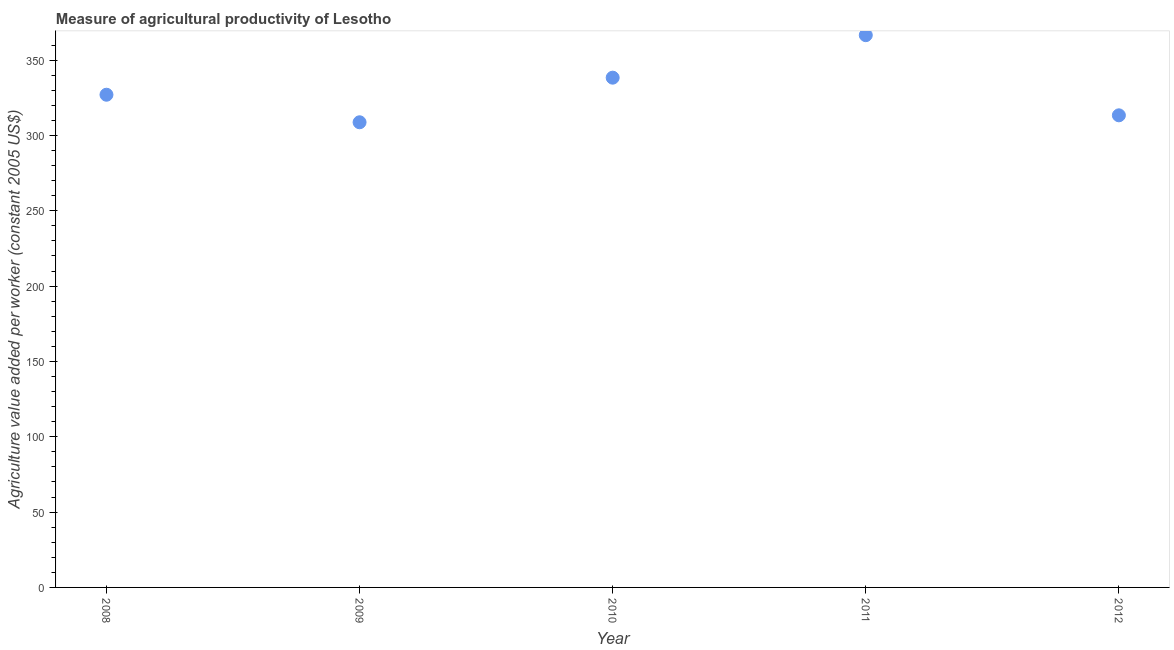What is the agriculture value added per worker in 2009?
Offer a very short reply. 308.73. Across all years, what is the maximum agriculture value added per worker?
Your answer should be very brief. 366.53. Across all years, what is the minimum agriculture value added per worker?
Ensure brevity in your answer.  308.73. In which year was the agriculture value added per worker maximum?
Your answer should be very brief. 2011. In which year was the agriculture value added per worker minimum?
Keep it short and to the point. 2009. What is the sum of the agriculture value added per worker?
Ensure brevity in your answer.  1653.95. What is the difference between the agriculture value added per worker in 2008 and 2012?
Offer a very short reply. 13.67. What is the average agriculture value added per worker per year?
Ensure brevity in your answer.  330.79. What is the median agriculture value added per worker?
Give a very brief answer. 327.01. What is the ratio of the agriculture value added per worker in 2010 to that in 2011?
Offer a very short reply. 0.92. Is the difference between the agriculture value added per worker in 2011 and 2012 greater than the difference between any two years?
Offer a very short reply. No. What is the difference between the highest and the second highest agriculture value added per worker?
Ensure brevity in your answer.  28.2. Is the sum of the agriculture value added per worker in 2009 and 2010 greater than the maximum agriculture value added per worker across all years?
Offer a very short reply. Yes. What is the difference between the highest and the lowest agriculture value added per worker?
Provide a short and direct response. 57.81. In how many years, is the agriculture value added per worker greater than the average agriculture value added per worker taken over all years?
Give a very brief answer. 2. Does the agriculture value added per worker monotonically increase over the years?
Keep it short and to the point. No. How many years are there in the graph?
Your answer should be very brief. 5. What is the difference between two consecutive major ticks on the Y-axis?
Provide a short and direct response. 50. Does the graph contain grids?
Make the answer very short. No. What is the title of the graph?
Keep it short and to the point. Measure of agricultural productivity of Lesotho. What is the label or title of the X-axis?
Provide a short and direct response. Year. What is the label or title of the Y-axis?
Your answer should be very brief. Agriculture value added per worker (constant 2005 US$). What is the Agriculture value added per worker (constant 2005 US$) in 2008?
Ensure brevity in your answer.  327.01. What is the Agriculture value added per worker (constant 2005 US$) in 2009?
Provide a succinct answer. 308.73. What is the Agriculture value added per worker (constant 2005 US$) in 2010?
Offer a terse response. 338.33. What is the Agriculture value added per worker (constant 2005 US$) in 2011?
Offer a terse response. 366.53. What is the Agriculture value added per worker (constant 2005 US$) in 2012?
Offer a very short reply. 313.34. What is the difference between the Agriculture value added per worker (constant 2005 US$) in 2008 and 2009?
Your response must be concise. 18.28. What is the difference between the Agriculture value added per worker (constant 2005 US$) in 2008 and 2010?
Keep it short and to the point. -11.33. What is the difference between the Agriculture value added per worker (constant 2005 US$) in 2008 and 2011?
Offer a very short reply. -39.53. What is the difference between the Agriculture value added per worker (constant 2005 US$) in 2008 and 2012?
Keep it short and to the point. 13.67. What is the difference between the Agriculture value added per worker (constant 2005 US$) in 2009 and 2010?
Keep it short and to the point. -29.61. What is the difference between the Agriculture value added per worker (constant 2005 US$) in 2009 and 2011?
Your response must be concise. -57.81. What is the difference between the Agriculture value added per worker (constant 2005 US$) in 2009 and 2012?
Ensure brevity in your answer.  -4.61. What is the difference between the Agriculture value added per worker (constant 2005 US$) in 2010 and 2011?
Make the answer very short. -28.2. What is the difference between the Agriculture value added per worker (constant 2005 US$) in 2010 and 2012?
Give a very brief answer. 24.99. What is the difference between the Agriculture value added per worker (constant 2005 US$) in 2011 and 2012?
Ensure brevity in your answer.  53.19. What is the ratio of the Agriculture value added per worker (constant 2005 US$) in 2008 to that in 2009?
Offer a terse response. 1.06. What is the ratio of the Agriculture value added per worker (constant 2005 US$) in 2008 to that in 2010?
Provide a short and direct response. 0.97. What is the ratio of the Agriculture value added per worker (constant 2005 US$) in 2008 to that in 2011?
Provide a short and direct response. 0.89. What is the ratio of the Agriculture value added per worker (constant 2005 US$) in 2008 to that in 2012?
Provide a succinct answer. 1.04. What is the ratio of the Agriculture value added per worker (constant 2005 US$) in 2009 to that in 2010?
Your answer should be very brief. 0.91. What is the ratio of the Agriculture value added per worker (constant 2005 US$) in 2009 to that in 2011?
Give a very brief answer. 0.84. What is the ratio of the Agriculture value added per worker (constant 2005 US$) in 2009 to that in 2012?
Your answer should be compact. 0.98. What is the ratio of the Agriculture value added per worker (constant 2005 US$) in 2010 to that in 2011?
Make the answer very short. 0.92. What is the ratio of the Agriculture value added per worker (constant 2005 US$) in 2011 to that in 2012?
Your answer should be very brief. 1.17. 